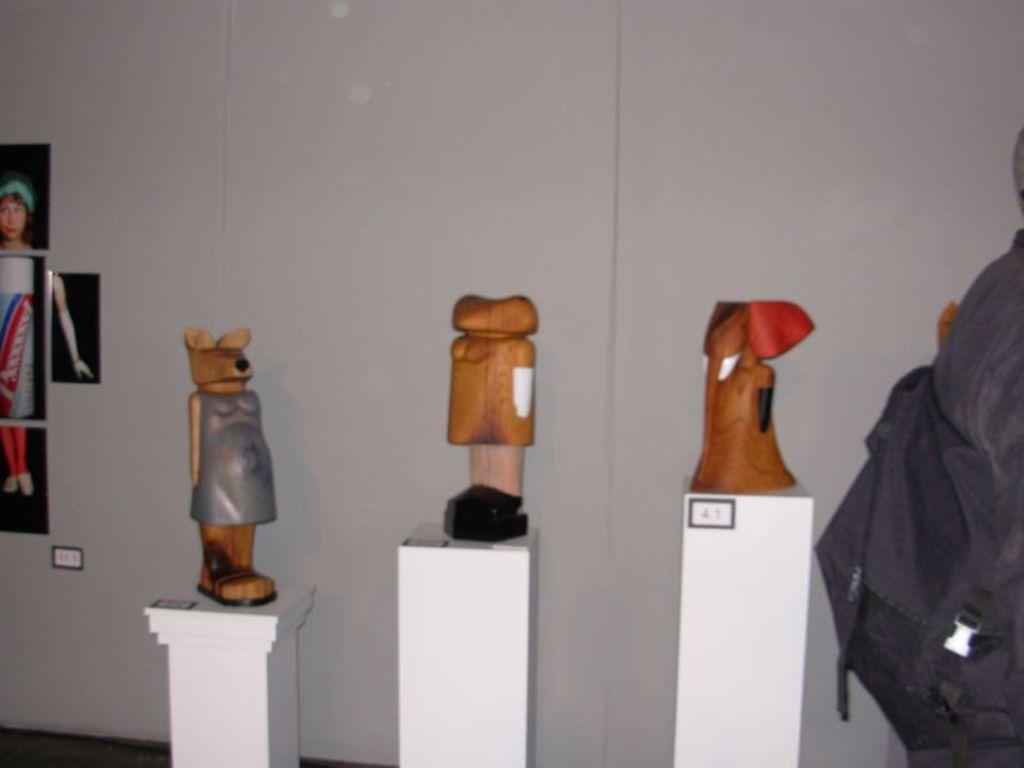Can you describe this image briefly? In this image I can see toys, photos on the wall and a bag which is black in color. These objects are on a white color objects. 